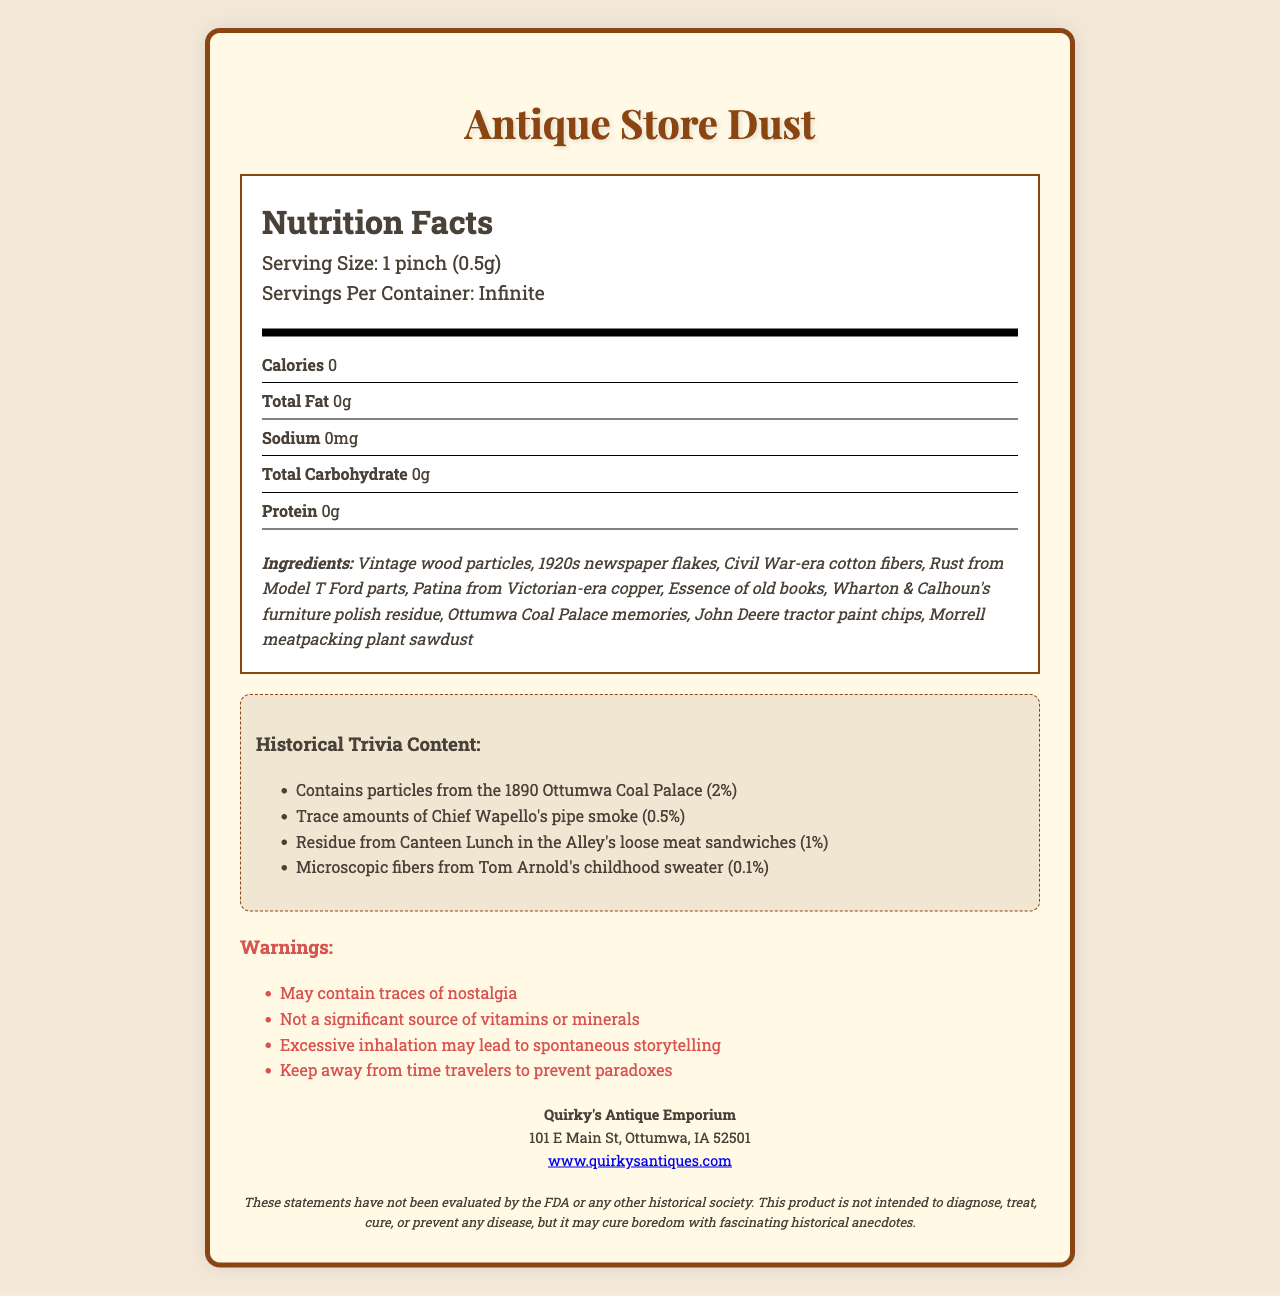what is the serving size of "Antique Store Dust"? The document states that the serving size is "1 pinch (0.5g)" in the serving information section.
Answer: 1 pinch (0.5g) how many servings per container are there? The document mentions that there are "Infinite" servings per container in the serving information section.
Answer: Infinite what is the total fat content in a serving of "Antique Store Dust"? The document lists the total fat content as "0g" in the nutrient information section.
Answer: 0g name at least three ingredients present in "Antique Store Dust." The ingredients section lists Vintage wood particles, 1920s newspaper flakes, and Civil War-era cotton fibers among others.
Answer: Vintage wood particles, 1920s newspaper flakes, Civil War-era cotton fibers what historical trivia particles are 0.5% present in "Antique Store Dust"? The historical trivia section mentioned "Trace amounts of Chief Wapello's pipe smoke" with a 0.5% presence.
Answer: Trace amounts of Chief Wapello's pipe smoke which of the following is a warning given for "Antique Store Dust"? A. May increase appetite B. May contain traces of nostalgia C. May cause allergies According to the warnings section, "May contain traces of nostalgia" is one of the warnings.
Answer: B. May contain traces of nostalgia which historical trivia fact has the highest percentage presence? A. Ottumwa Coal Palace particles B. John Deere tractor paint chips C. Canteen Lunch in the Alley's loose meat sandwich residue The historical trivia section indicates that particles from the Ottumwa Coal Palace have the highest presence at 2%.
Answer: A. Ottumwa Coal Palace particles is "Antique Store Dust" a significant source of vitamins or minerals? The warnings section explicitly states that this product is "Not a significant source of vitamins or minerals."
Answer: No does the document mention if "Antique Store Dust" contains calories? The document states "Calories: 0" in the nutrient information section.
Answer: No what is the main idea of the document? The document contains various sections, including serving size, ingredients, historical trivia, warnings, and manufacturer details, all with humorous and creative content.
Answer: The document humorously presents a nutrition facts label for "Antique Store Dust," listing whimsical ingredients and historical trivia with zero nutritional value while including warnings and manufacturer information. who is the manufacturer of "Antique Store Dust"? The manufacturer information section lists "Quirky's Antique Emporium" as the manufacturer along with its address and website.
Answer: Quirky's Antique Emporium what percentage of Tom Arnold's childhood sweater fibers are present in "Antique Store Dust"? The historical trivia section lists microscopic fibers from Tom Arnold's childhood sweater as being present at 0.1%.
Answer: 0.1% where can you buy "Antique Store Dust"? Although the document mentions the manufacturer info, including the store's address and website, it does not specifically indicate where or how to purchase the product.
Answer: Cannot be determined 